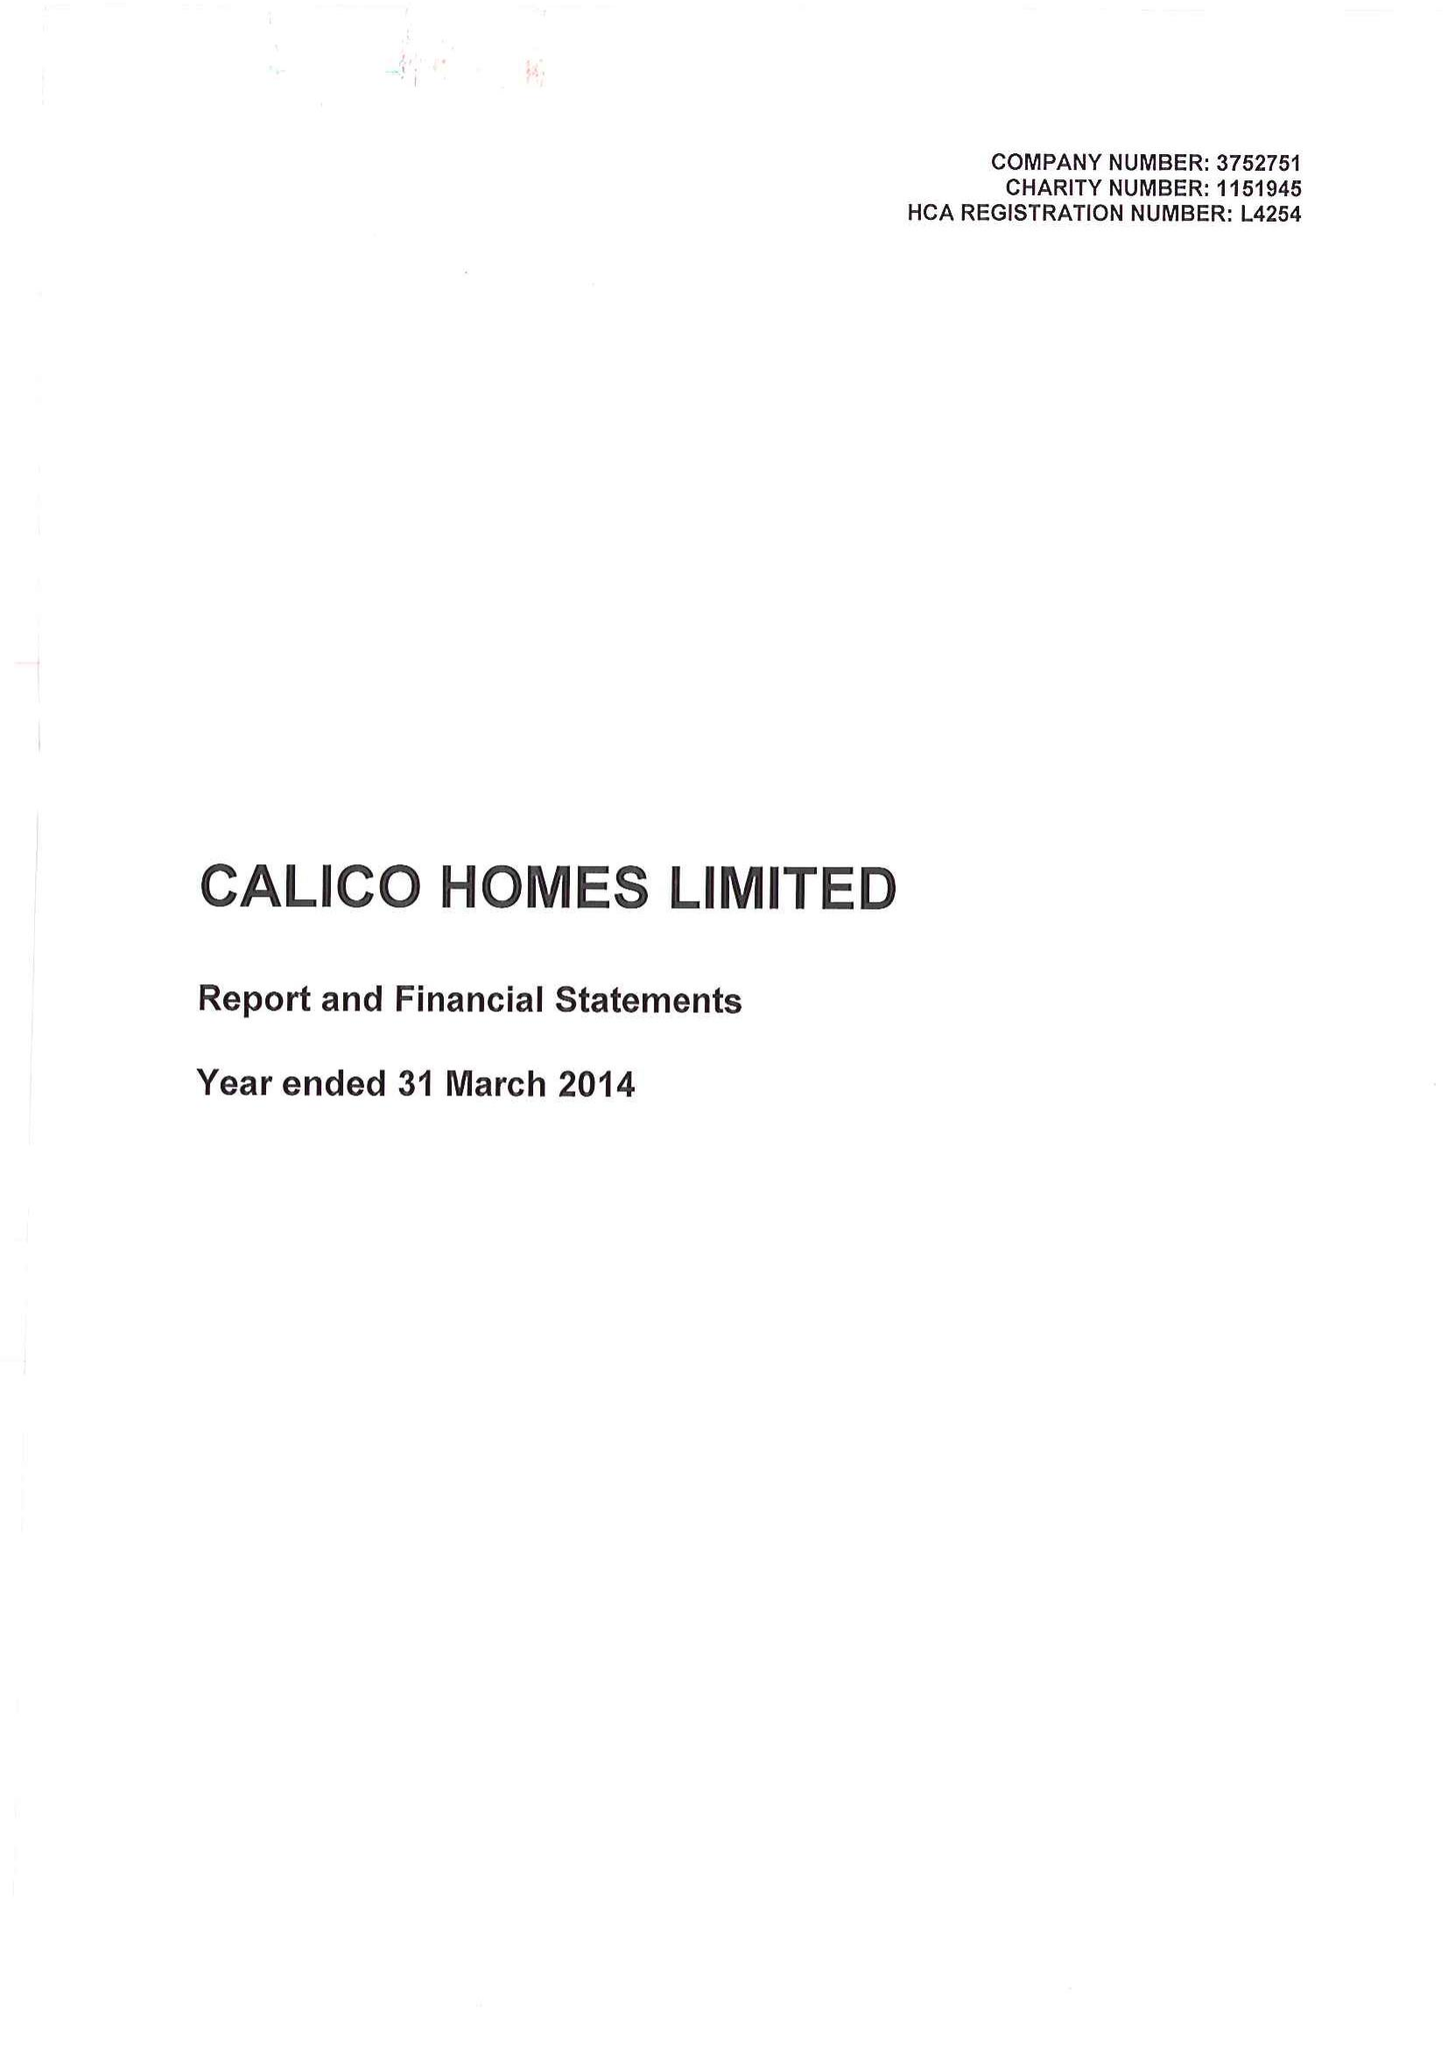What is the value for the spending_annually_in_british_pounds?
Answer the question using a single word or phrase. 21557000.00 